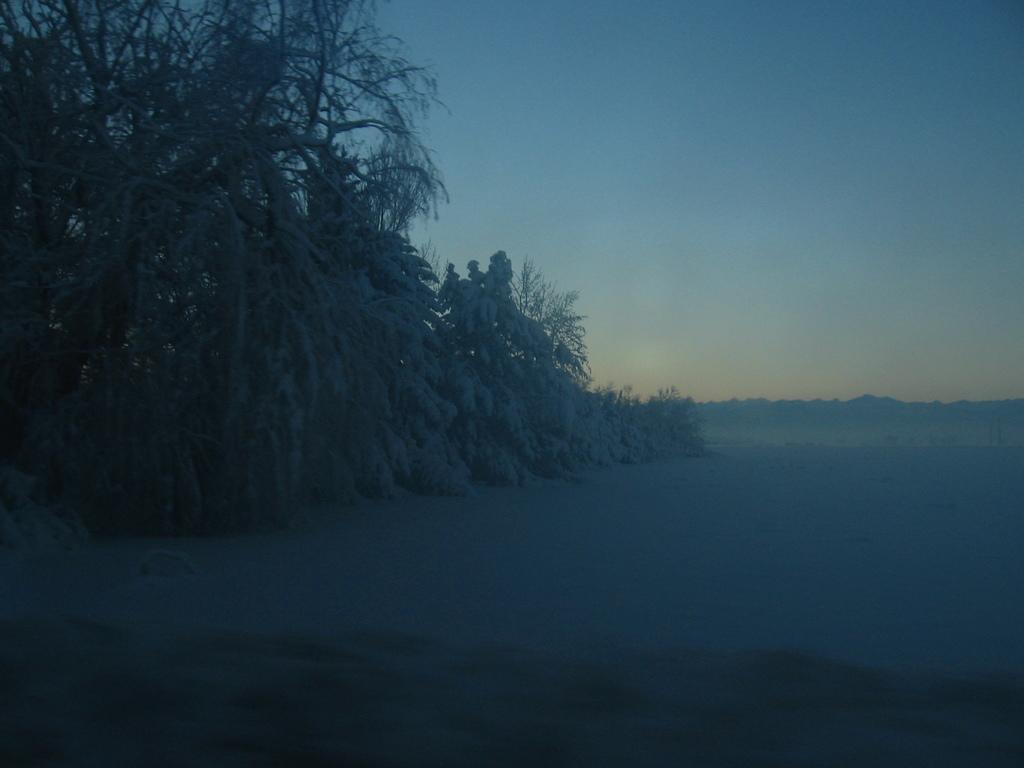How would you summarize this image in a sentence or two? In this image we can see a land covered with snow and trees. The sky is in blue color. 